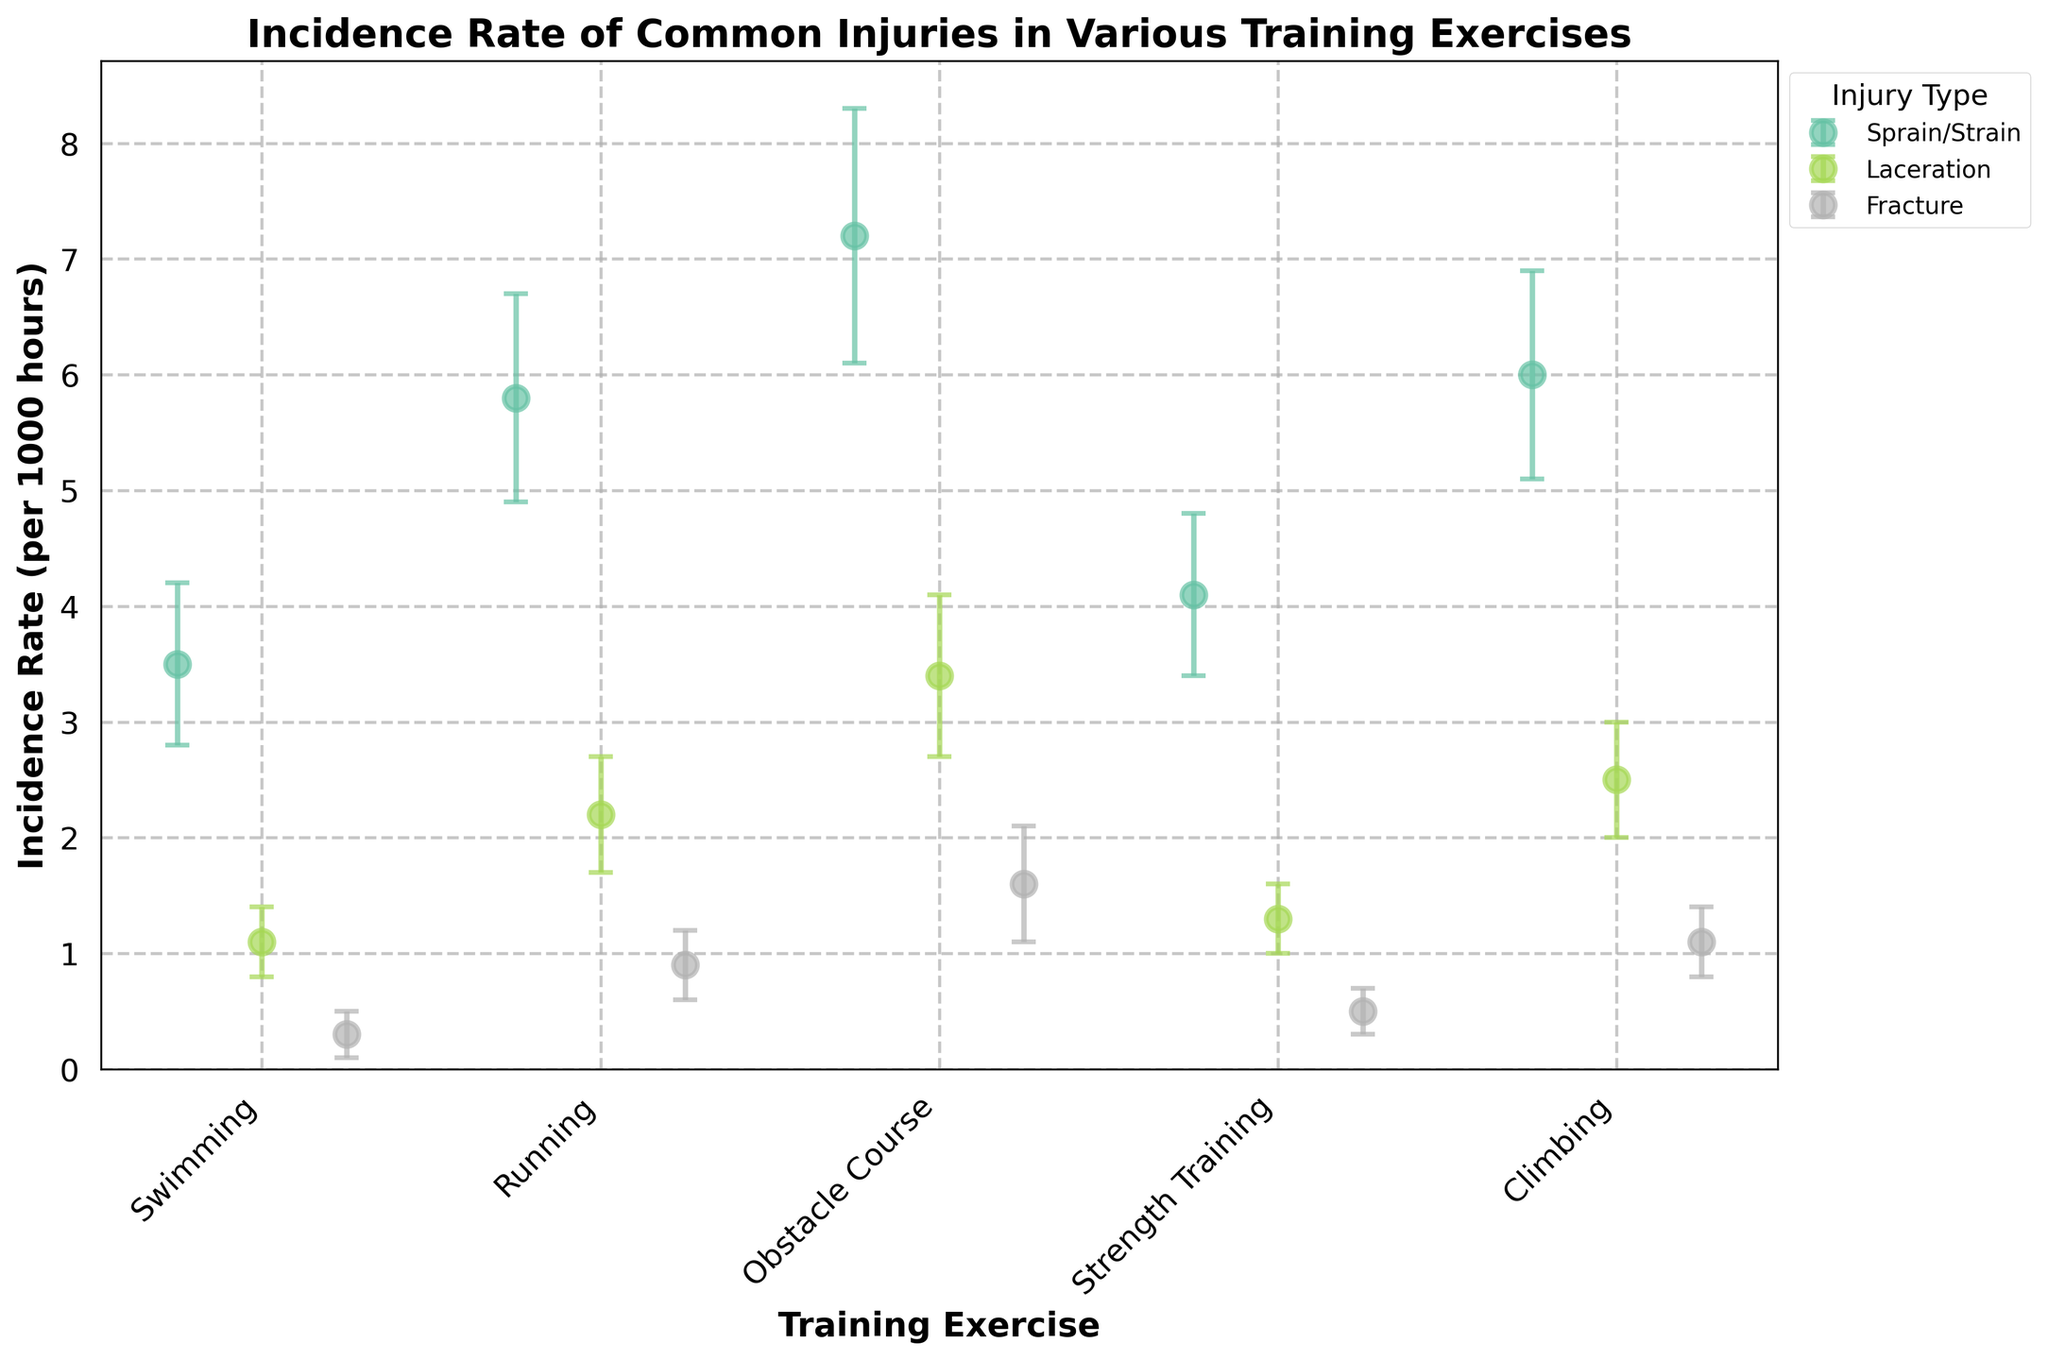What's the title of the figure? The title is usually found at the top of the figure. In this case, it is written in bold and states the primary focus of the plot.
Answer: Incidence Rate of Common Injuries in Various Training Exercises What is the incidence rate of sprain/strain in running? Locate the dot that corresponds to sprain/strain in the running category, then read the value on the y-axis where the dot is positioned.
Answer: 5.8 (per 1000 hours) Which training exercise has the highest incidence rate for fractures? Compare the positions of the dots representing fractures across all exercises. The highest dot indicates the highest incidence rate.
Answer: Obstacle Course How does the incidence rate of lacerations in climbing compare with that in swimming? Identify the dots for lacerations in both climbing and swimming, then compare their positions on the y-axis.
Answer: Climbing (2.5) is higher than Swimming (1.1) Which injury type in strength training has the largest confidence interval? Look at the error bars for each injury type in strength training. The larger distance between the upper and lower bounds indicates a larger confidence interval.
Answer: Sprain/Strain What is the range of the incidence rate of sprain/strain in the obstacle course? The range is given by the lower and upper bounds of the error bars for sprain/strain in the obstacle course. Subtract the lower bound from the upper bound.
Answer: 2.2 (from 6.1 to 8.3) What is the difference in the upper bounds of the confidence intervals for fractures between running and swimming? Locate the upper bounds for fractures in both running and swimming, then subtract the upper bound for swimming from the upper bound for running.
Answer: 0.7 (1.2-0.5) Which training exercise has the lowest incidence rate for lacerations? Identify the lowest dot representing lacerations across all training exercises by comparing their positions on the y-axis.
Answer: Swimming In which training exercise is the incidence rate for lacerations almost equal to the confidence interval range for sprain/strain? Compare the incidence rates for lacerations with the confidence interval ranges for sprain/strains across all exercises, finding a close match.
Answer: Climbing (Laceration Incidence ≈ 2.5, Sprain/Strain CI range ≈ 1.8) What is the average lower bound confidence interval for fractures across all training exercises? Sum up all the lower bounds for fractures across activities, then divide by their count. Lower bounds: 0.1 (Swimming) + 0.6 (Running) + 1.1 (Obstacle Course) + 0.3 (Strength Training) + 0.8 (Climbing). Sum = 2.9, divided by 5 = 0.58
Answer: 0.58 